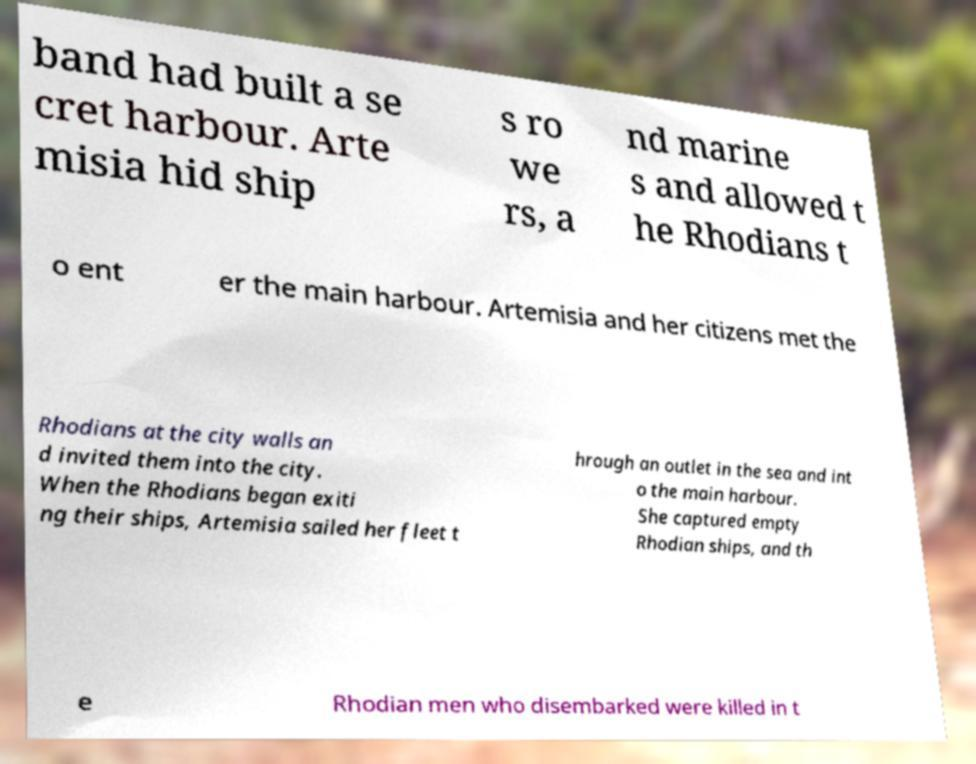What messages or text are displayed in this image? I need them in a readable, typed format. band had built a se cret harbour. Arte misia hid ship s ro we rs, a nd marine s and allowed t he Rhodians t o ent er the main harbour. Artemisia and her citizens met the Rhodians at the city walls an d invited them into the city. When the Rhodians began exiti ng their ships, Artemisia sailed her fleet t hrough an outlet in the sea and int o the main harbour. She captured empty Rhodian ships, and th e Rhodian men who disembarked were killed in t 